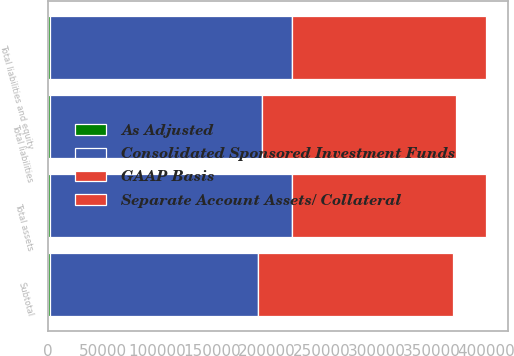Convert chart. <chart><loc_0><loc_0><loc_500><loc_500><stacked_bar_chart><ecel><fcel>Subtotal<fcel>Total assets<fcel>Total liabilities<fcel>Total liabilities and equity<nl><fcel>Consolidated Sponsored Investment Funds<fcel>189392<fcel>219873<fcel>193203<fcel>219873<nl><fcel>Separate Account Assets/ Collateral<fcel>176901<fcel>176901<fcel>176901<fcel>176901<nl><fcel>As Adjusted<fcel>2486<fcel>2486<fcel>2443<fcel>2486<nl><fcel>GAAP Basis<fcel>228<fcel>228<fcel>39<fcel>228<nl></chart> 